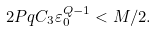<formula> <loc_0><loc_0><loc_500><loc_500>2 P q C _ { 3 } \varepsilon _ { 0 } ^ { Q - 1 } < M / 2 .</formula> 